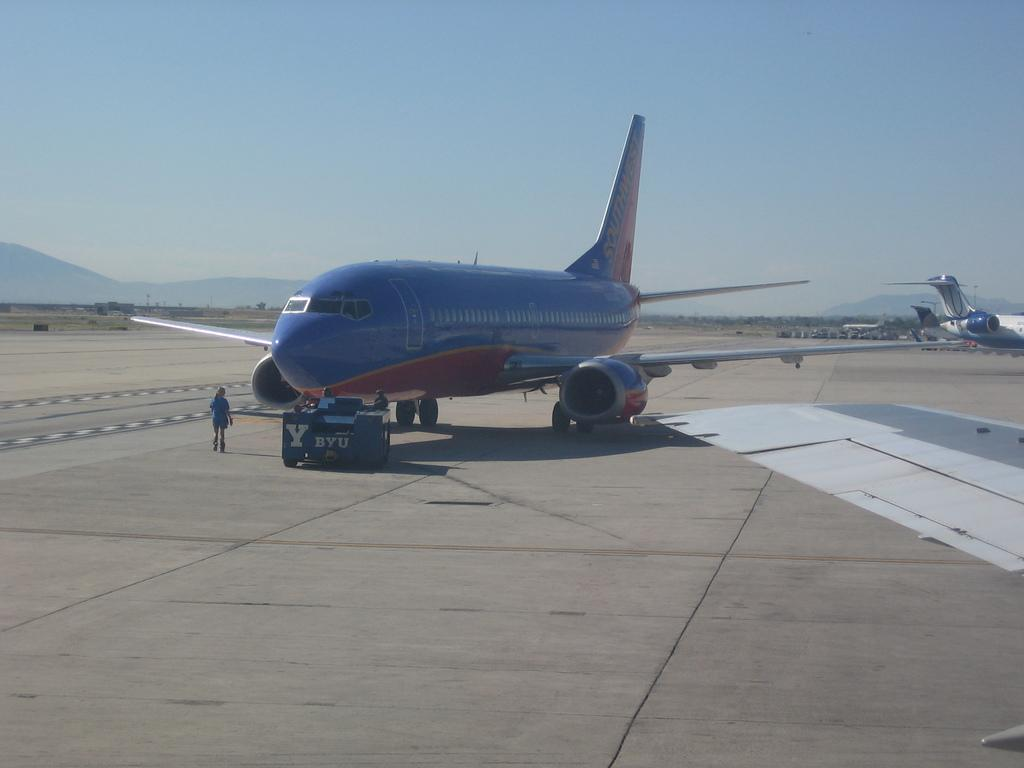<image>
Offer a succinct explanation of the picture presented. A Southwest airplane is on a runway with someone walking nearby. 